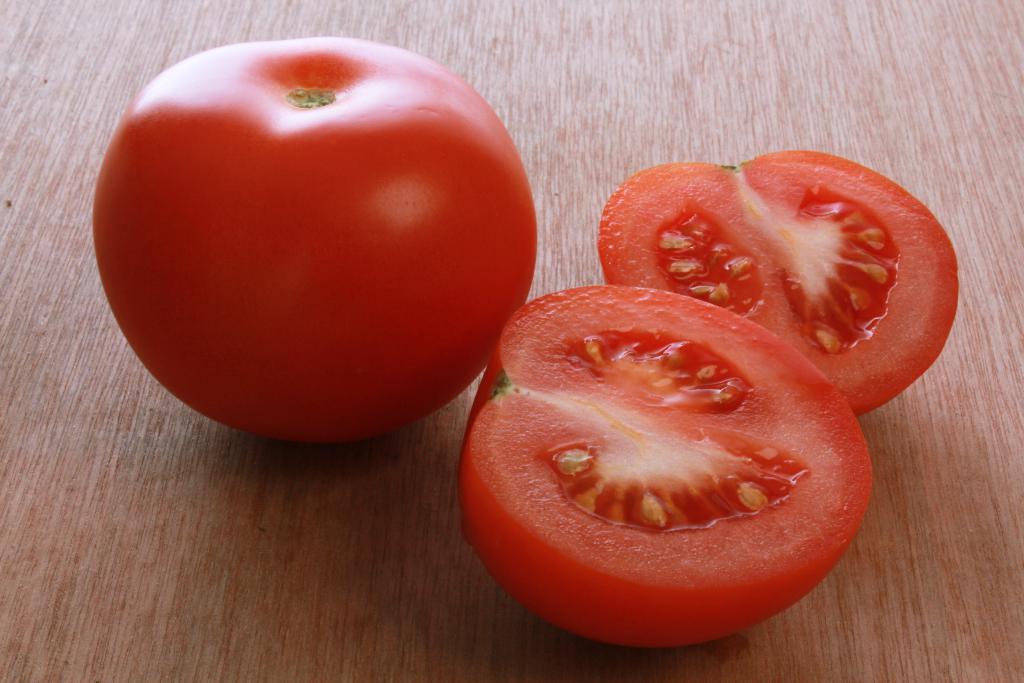Please provide a concise description of this image. In this image I can see a tomato and its two pieces kept on a table. This image is taken may be in a room. 